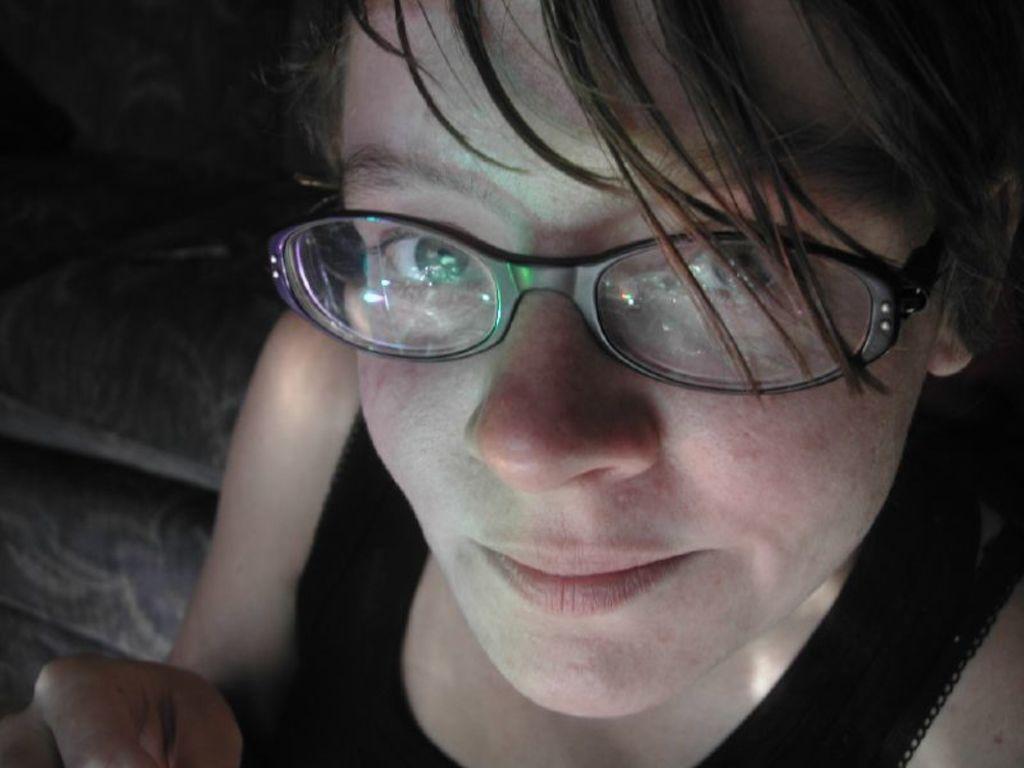Could you give a brief overview of what you see in this image? In this image I can see a person wearing black dress and the person is also wearing spectacles and I can see dark background. 